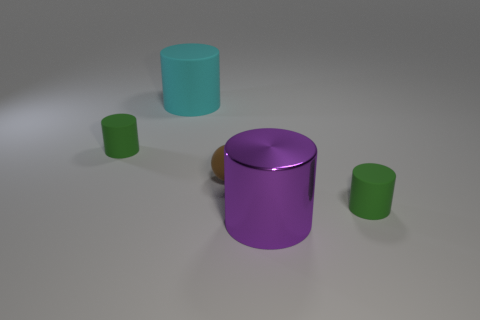Is the shape of the large thing in front of the tiny sphere the same as the object that is to the right of the big purple metal cylinder?
Provide a short and direct response. Yes. How many small things are both left of the large purple cylinder and right of the large cyan matte cylinder?
Your response must be concise. 1. What number of other objects are there of the same size as the purple metallic cylinder?
Give a very brief answer. 1. The thing that is to the right of the large cyan cylinder and left of the purple thing is made of what material?
Make the answer very short. Rubber. There is a big rubber cylinder; is its color the same as the small cylinder to the right of the metallic thing?
Offer a terse response. No. There is a cyan matte object that is the same shape as the big purple shiny object; what size is it?
Make the answer very short. Large. There is a object that is both behind the big purple object and in front of the sphere; what is its shape?
Make the answer very short. Cylinder. Is the size of the cyan thing the same as the green rubber thing on the right side of the brown ball?
Your answer should be compact. No. There is a big matte thing that is the same shape as the big purple shiny object; what color is it?
Keep it short and to the point. Cyan. Do the green cylinder to the left of the rubber ball and the green matte object right of the cyan cylinder have the same size?
Offer a very short reply. Yes. 